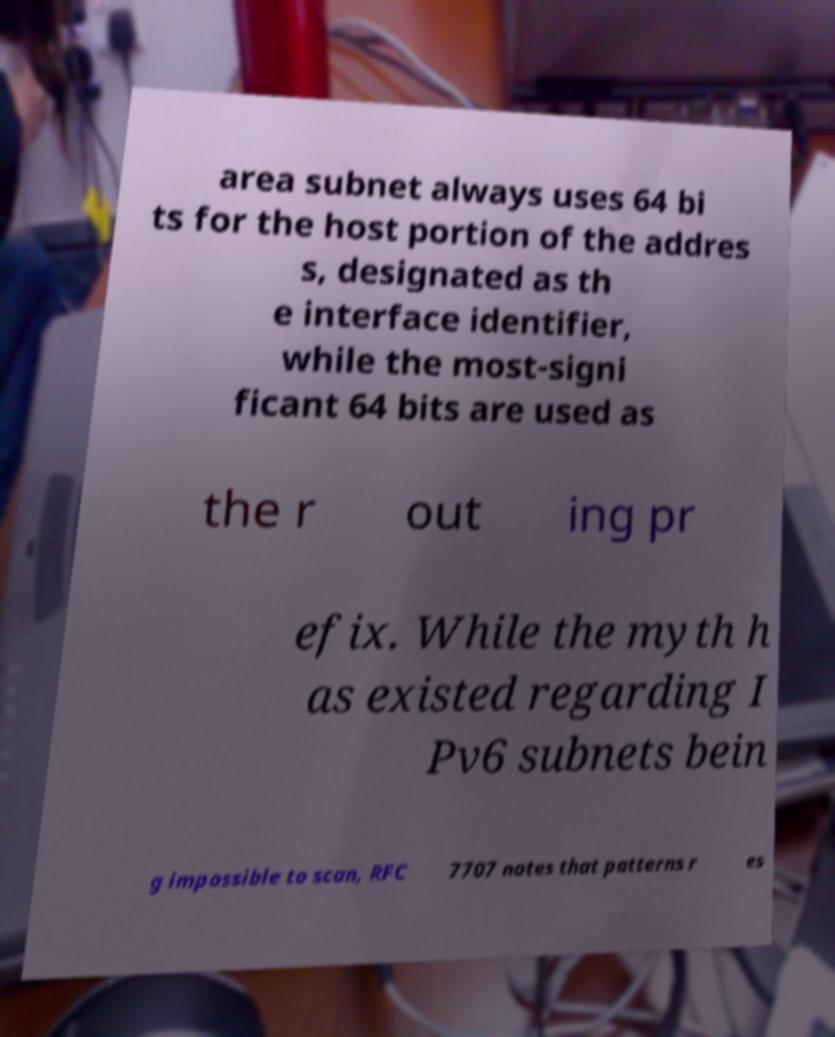For documentation purposes, I need the text within this image transcribed. Could you provide that? area subnet always uses 64 bi ts for the host portion of the addres s, designated as th e interface identifier, while the most-signi ficant 64 bits are used as the r out ing pr efix. While the myth h as existed regarding I Pv6 subnets bein g impossible to scan, RFC 7707 notes that patterns r es 